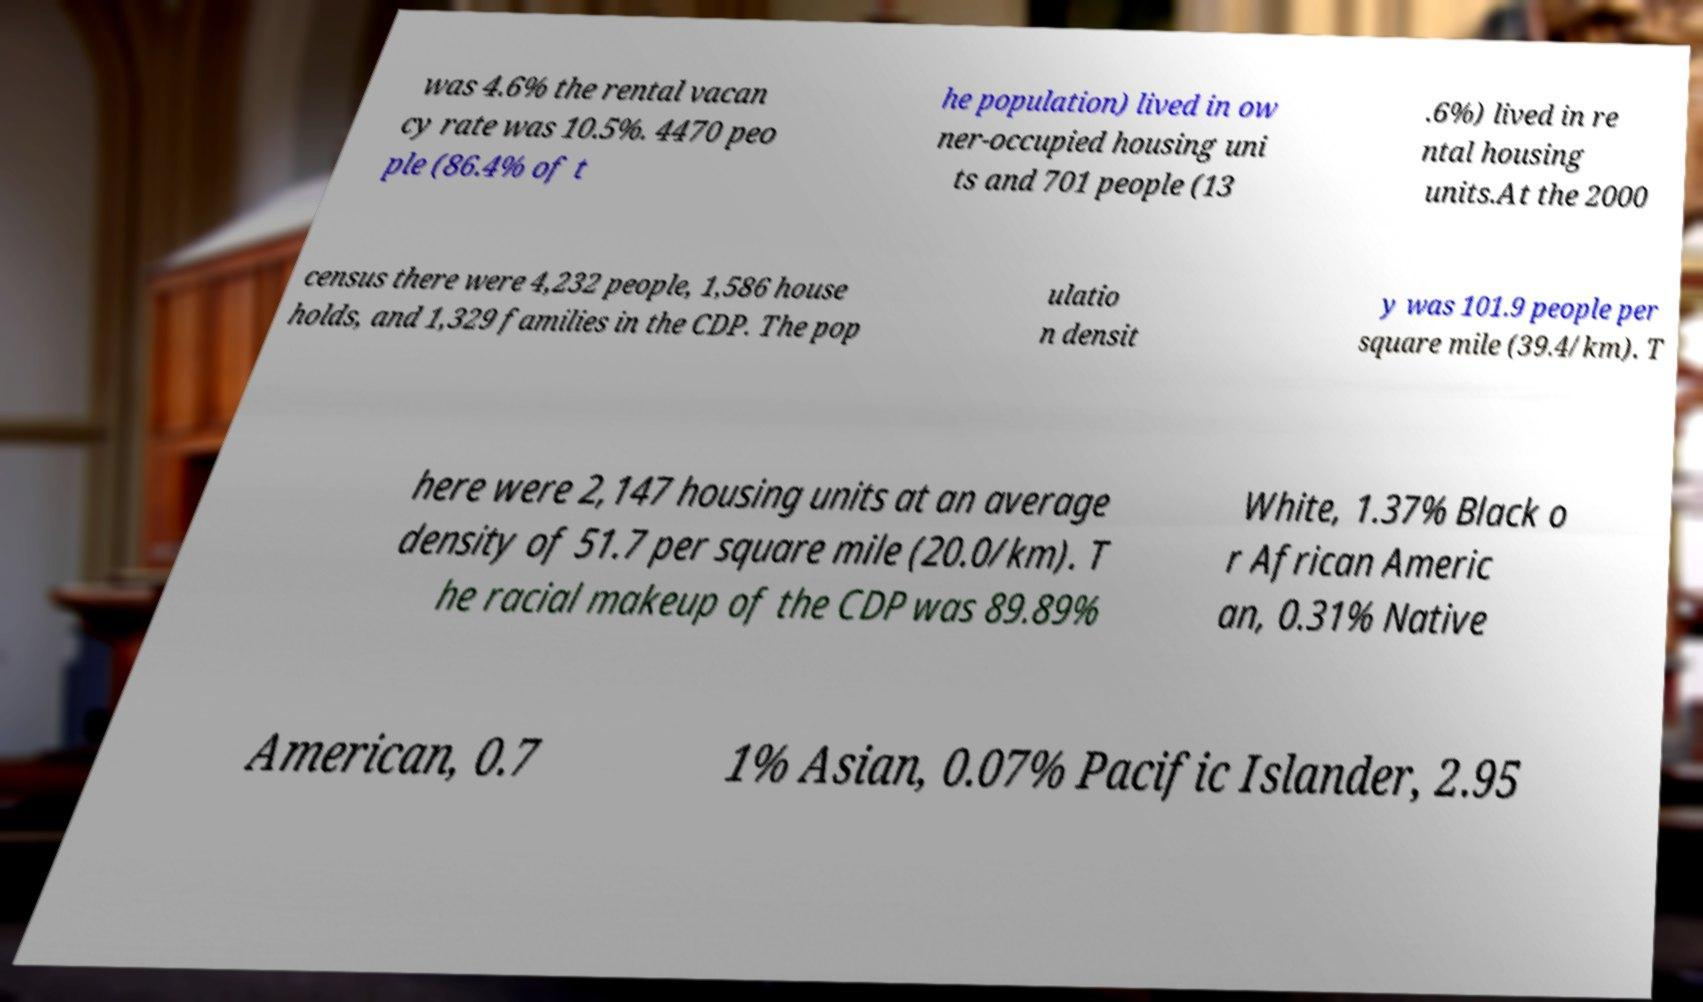Can you accurately transcribe the text from the provided image for me? was 4.6% the rental vacan cy rate was 10.5%. 4470 peo ple (86.4% of t he population) lived in ow ner-occupied housing uni ts and 701 people (13 .6%) lived in re ntal housing units.At the 2000 census there were 4,232 people, 1,586 house holds, and 1,329 families in the CDP. The pop ulatio n densit y was 101.9 people per square mile (39.4/km). T here were 2,147 housing units at an average density of 51.7 per square mile (20.0/km). T he racial makeup of the CDP was 89.89% White, 1.37% Black o r African Americ an, 0.31% Native American, 0.7 1% Asian, 0.07% Pacific Islander, 2.95 